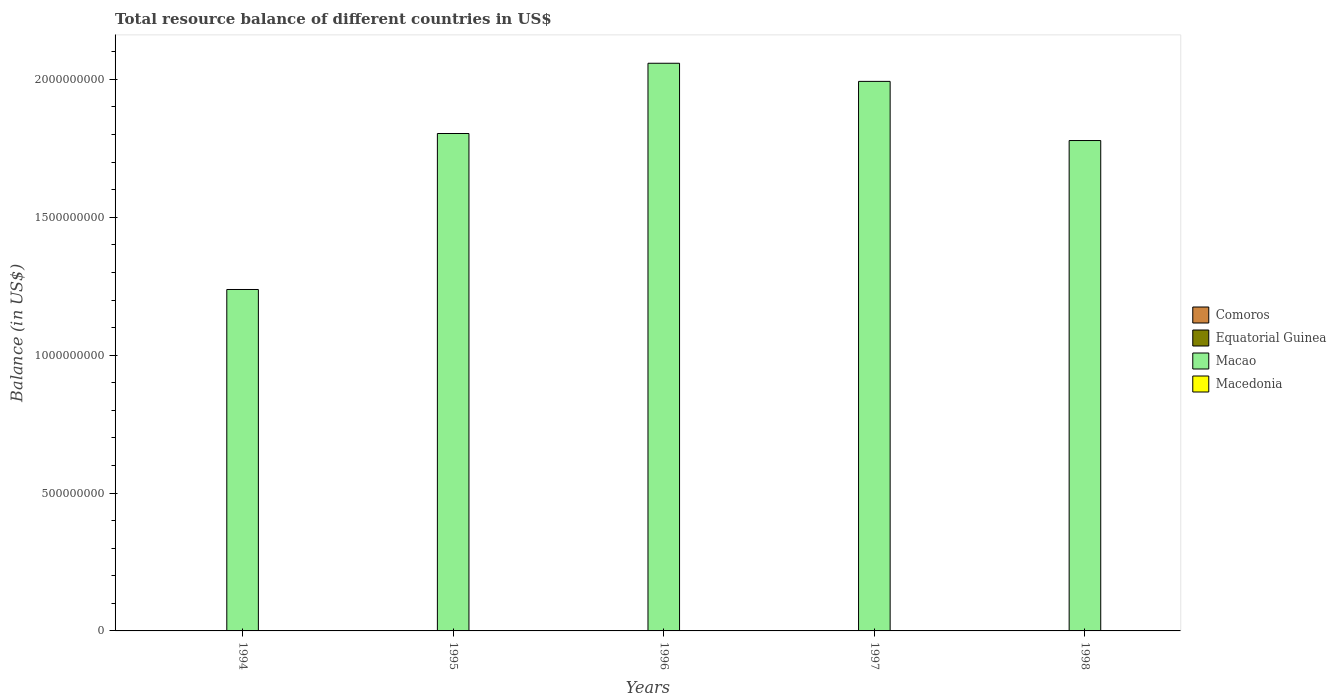Are the number of bars per tick equal to the number of legend labels?
Keep it short and to the point. No. How many bars are there on the 5th tick from the left?
Make the answer very short. 1. What is the label of the 5th group of bars from the left?
Provide a succinct answer. 1998. What is the total resource balance in Macao in 1994?
Provide a short and direct response. 1.24e+09. Across all years, what is the maximum total resource balance in Macao?
Offer a very short reply. 2.06e+09. What is the total total resource balance in Macao in the graph?
Your response must be concise. 8.87e+09. What is the difference between the total resource balance in Macao in 1995 and that in 1997?
Your response must be concise. -1.89e+08. What is the difference between the total resource balance in Equatorial Guinea in 1997 and the total resource balance in Macao in 1996?
Provide a succinct answer. -2.06e+09. What is the average total resource balance in Macao per year?
Offer a very short reply. 1.77e+09. In how many years, is the total resource balance in Macedonia greater than 800000000 US$?
Give a very brief answer. 0. What is the ratio of the total resource balance in Macao in 1995 to that in 1996?
Keep it short and to the point. 0.88. What is the difference between the highest and the lowest total resource balance in Macao?
Keep it short and to the point. 8.20e+08. How many years are there in the graph?
Ensure brevity in your answer.  5. Are the values on the major ticks of Y-axis written in scientific E-notation?
Ensure brevity in your answer.  No. Where does the legend appear in the graph?
Provide a succinct answer. Center right. What is the title of the graph?
Offer a terse response. Total resource balance of different countries in US$. Does "Ireland" appear as one of the legend labels in the graph?
Offer a very short reply. No. What is the label or title of the X-axis?
Provide a short and direct response. Years. What is the label or title of the Y-axis?
Offer a very short reply. Balance (in US$). What is the Balance (in US$) of Comoros in 1994?
Make the answer very short. 0. What is the Balance (in US$) of Macao in 1994?
Your answer should be compact. 1.24e+09. What is the Balance (in US$) of Macedonia in 1994?
Make the answer very short. 0. What is the Balance (in US$) in Equatorial Guinea in 1995?
Ensure brevity in your answer.  0. What is the Balance (in US$) in Macao in 1995?
Your answer should be compact. 1.80e+09. What is the Balance (in US$) in Macedonia in 1995?
Make the answer very short. 0. What is the Balance (in US$) of Comoros in 1996?
Give a very brief answer. 0. What is the Balance (in US$) in Macao in 1996?
Your answer should be very brief. 2.06e+09. What is the Balance (in US$) in Macedonia in 1996?
Your answer should be compact. 0. What is the Balance (in US$) of Comoros in 1997?
Provide a succinct answer. 0. What is the Balance (in US$) of Equatorial Guinea in 1997?
Keep it short and to the point. 0. What is the Balance (in US$) of Macao in 1997?
Ensure brevity in your answer.  1.99e+09. What is the Balance (in US$) in Macedonia in 1997?
Make the answer very short. 0. What is the Balance (in US$) of Equatorial Guinea in 1998?
Offer a very short reply. 0. What is the Balance (in US$) of Macao in 1998?
Your answer should be compact. 1.78e+09. What is the Balance (in US$) in Macedonia in 1998?
Your response must be concise. 0. Across all years, what is the maximum Balance (in US$) in Macao?
Your response must be concise. 2.06e+09. Across all years, what is the minimum Balance (in US$) of Macao?
Offer a terse response. 1.24e+09. What is the total Balance (in US$) in Comoros in the graph?
Provide a succinct answer. 0. What is the total Balance (in US$) in Macao in the graph?
Offer a terse response. 8.87e+09. What is the total Balance (in US$) in Macedonia in the graph?
Ensure brevity in your answer.  0. What is the difference between the Balance (in US$) in Macao in 1994 and that in 1995?
Give a very brief answer. -5.66e+08. What is the difference between the Balance (in US$) in Macao in 1994 and that in 1996?
Offer a very short reply. -8.20e+08. What is the difference between the Balance (in US$) of Macao in 1994 and that in 1997?
Make the answer very short. -7.55e+08. What is the difference between the Balance (in US$) in Macao in 1994 and that in 1998?
Provide a short and direct response. -5.40e+08. What is the difference between the Balance (in US$) in Macao in 1995 and that in 1996?
Your answer should be compact. -2.55e+08. What is the difference between the Balance (in US$) of Macao in 1995 and that in 1997?
Provide a short and direct response. -1.89e+08. What is the difference between the Balance (in US$) of Macao in 1995 and that in 1998?
Offer a terse response. 2.55e+07. What is the difference between the Balance (in US$) in Macao in 1996 and that in 1997?
Give a very brief answer. 6.57e+07. What is the difference between the Balance (in US$) in Macao in 1996 and that in 1998?
Your answer should be very brief. 2.80e+08. What is the difference between the Balance (in US$) of Macao in 1997 and that in 1998?
Keep it short and to the point. 2.15e+08. What is the average Balance (in US$) in Equatorial Guinea per year?
Make the answer very short. 0. What is the average Balance (in US$) in Macao per year?
Your answer should be very brief. 1.77e+09. What is the average Balance (in US$) of Macedonia per year?
Provide a succinct answer. 0. What is the ratio of the Balance (in US$) in Macao in 1994 to that in 1995?
Your response must be concise. 0.69. What is the ratio of the Balance (in US$) of Macao in 1994 to that in 1996?
Give a very brief answer. 0.6. What is the ratio of the Balance (in US$) of Macao in 1994 to that in 1997?
Your answer should be very brief. 0.62. What is the ratio of the Balance (in US$) in Macao in 1994 to that in 1998?
Your answer should be very brief. 0.7. What is the ratio of the Balance (in US$) of Macao in 1995 to that in 1996?
Make the answer very short. 0.88. What is the ratio of the Balance (in US$) of Macao in 1995 to that in 1997?
Your answer should be very brief. 0.91. What is the ratio of the Balance (in US$) in Macao in 1995 to that in 1998?
Your answer should be compact. 1.01. What is the ratio of the Balance (in US$) of Macao in 1996 to that in 1997?
Keep it short and to the point. 1.03. What is the ratio of the Balance (in US$) of Macao in 1996 to that in 1998?
Provide a short and direct response. 1.16. What is the ratio of the Balance (in US$) in Macao in 1997 to that in 1998?
Your answer should be very brief. 1.12. What is the difference between the highest and the second highest Balance (in US$) of Macao?
Offer a very short reply. 6.57e+07. What is the difference between the highest and the lowest Balance (in US$) in Macao?
Keep it short and to the point. 8.20e+08. 